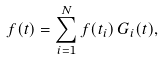<formula> <loc_0><loc_0><loc_500><loc_500>f ( t ) = \sum _ { i = 1 } ^ { N } f ( t _ { i } ) \, G _ { i } ( t ) ,</formula> 